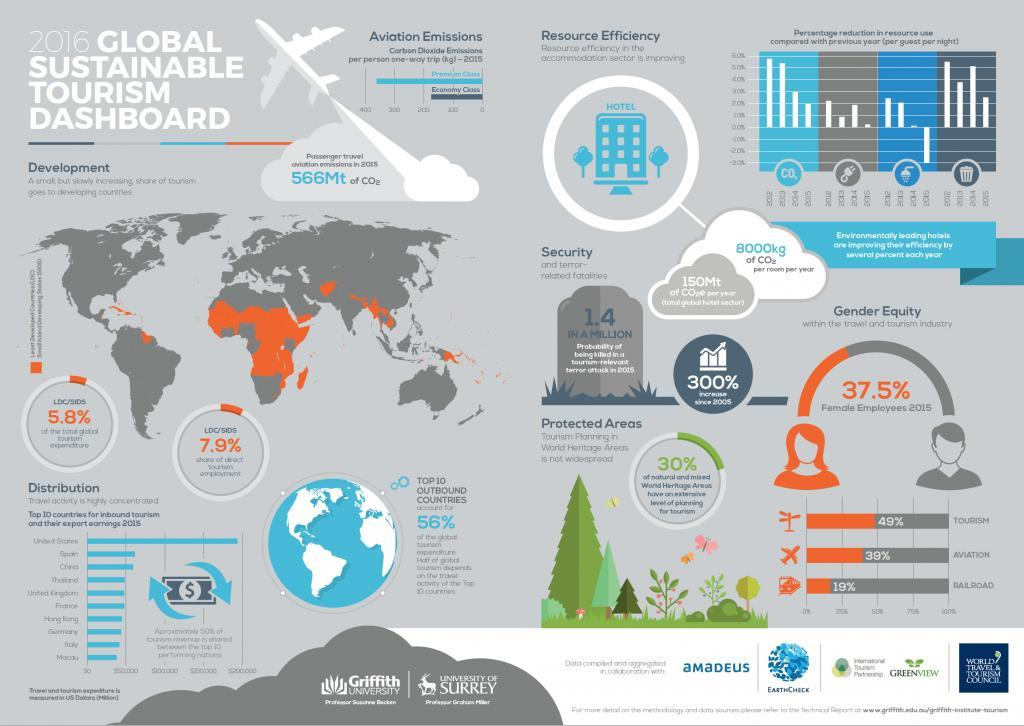What was the percentage of male employees in the 'travel and tourism industry' in 2015?
Answer the question with a short phrase. 62.5 What was the percentage of female employees in the 'travel and tourism industry' in 2015? 37.5% Which travel and tourism industry has more males than females - Aviation, railroad or tourism? Railroad What percentage of the aviation industry is females? 39% Which are the top 3 countries for inbound tourism? United States, Spain, China By what percentage has the probability of being killed in a tourism related terror attack,  increased since 2005? 300% Which are the 2 flight classes mentioned? Premium class, economy class What percentage of railroad industry employees are males? 81% What was the probability of being killed in a tourism relevant terror attack in 2015? 1.4 in a million Which airline class has a higher carbon dioxide emission? Premium class 